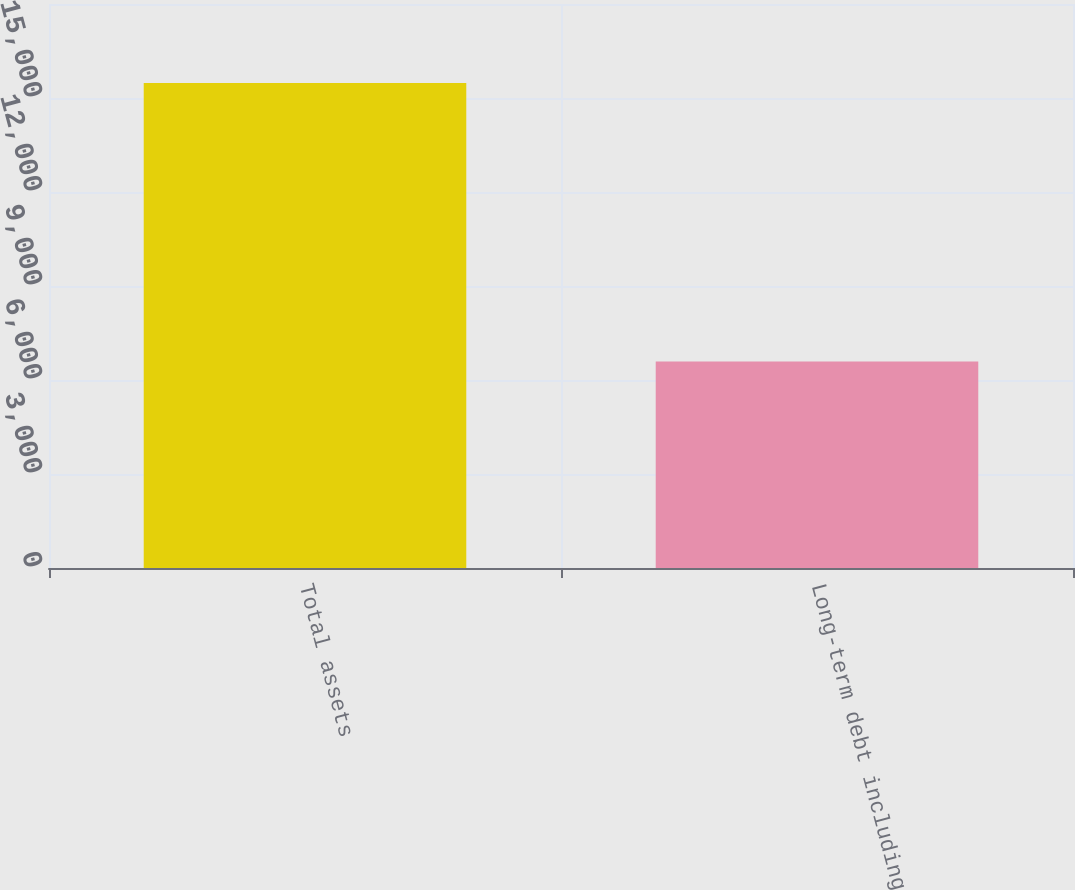<chart> <loc_0><loc_0><loc_500><loc_500><bar_chart><fcel>Total assets<fcel>Long-term debt including<nl><fcel>15480<fcel>6590<nl></chart> 